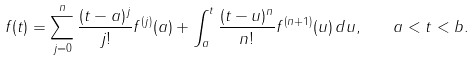Convert formula to latex. <formula><loc_0><loc_0><loc_500><loc_500>f ( t ) = \sum _ { j = 0 } ^ { n } \frac { ( t - a ) ^ { j } } { j ! } f ^ { ( j ) } ( a ) + \int _ { a } ^ { t } \frac { ( t - u ) ^ { n } } { n ! } f ^ { ( n + 1 ) } ( u ) \, d u , \quad a < t < b .</formula> 